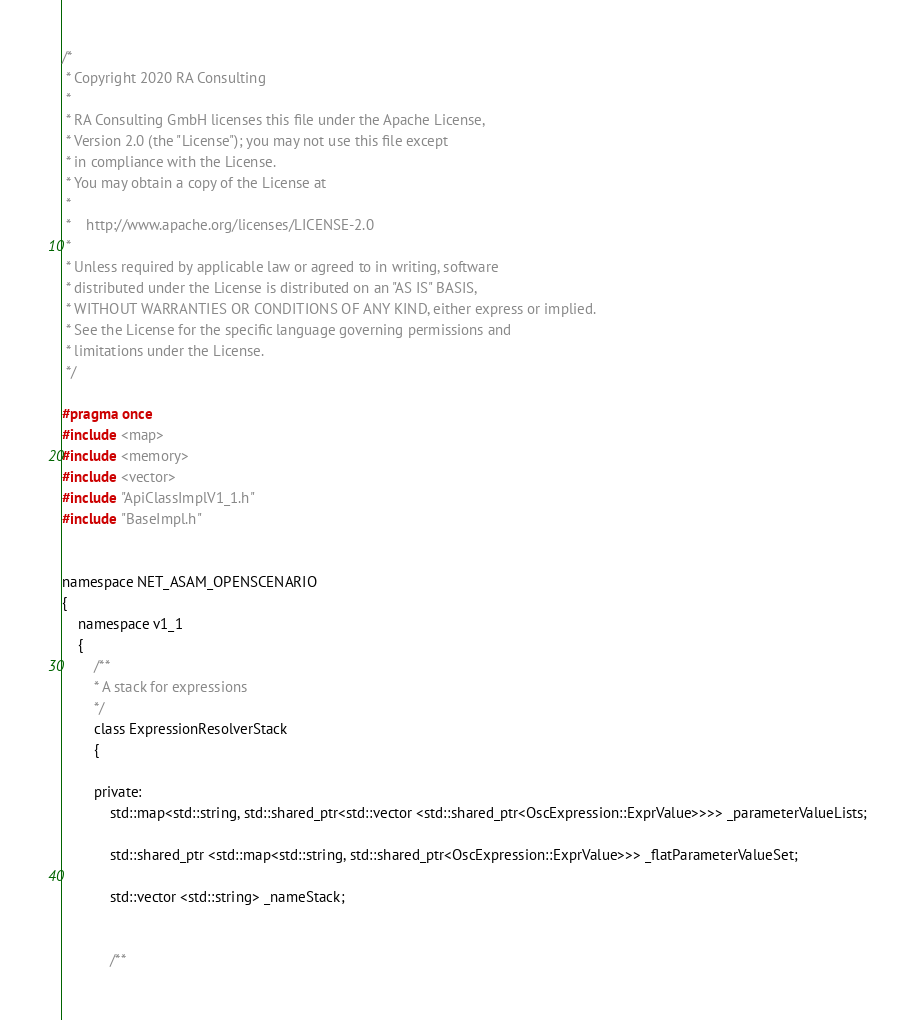<code> <loc_0><loc_0><loc_500><loc_500><_C_>/*
 * Copyright 2020 RA Consulting
 *
 * RA Consulting GmbH licenses this file under the Apache License,
 * Version 2.0 (the "License"); you may not use this file except
 * in compliance with the License.
 * You may obtain a copy of the License at
 *
 *    http://www.apache.org/licenses/LICENSE-2.0
 *
 * Unless required by applicable law or agreed to in writing, software
 * distributed under the License is distributed on an "AS IS" BASIS,
 * WITHOUT WARRANTIES OR CONDITIONS OF ANY KIND, either express or implied.
 * See the License for the specific language governing permissions and
 * limitations under the License.
 */

#pragma once
#include <map>
#include <memory>
#include <vector>
#include "ApiClassImplV1_1.h"
#include "BaseImpl.h"


namespace NET_ASAM_OPENSCENARIO
{
    namespace v1_1
    {
        /**
        * A stack for expressions
        */
        class ExpressionResolverStack
        {

        private:
			std::map<std::string, std::shared_ptr<std::vector <std::shared_ptr<OscExpression::ExprValue>>>> _parameterValueLists;
        	
			std::shared_ptr <std::map<std::string, std::shared_ptr<OscExpression::ExprValue>>> _flatParameterValueSet;
        	
			std::vector <std::string> _nameStack;

			
        	/**</code> 